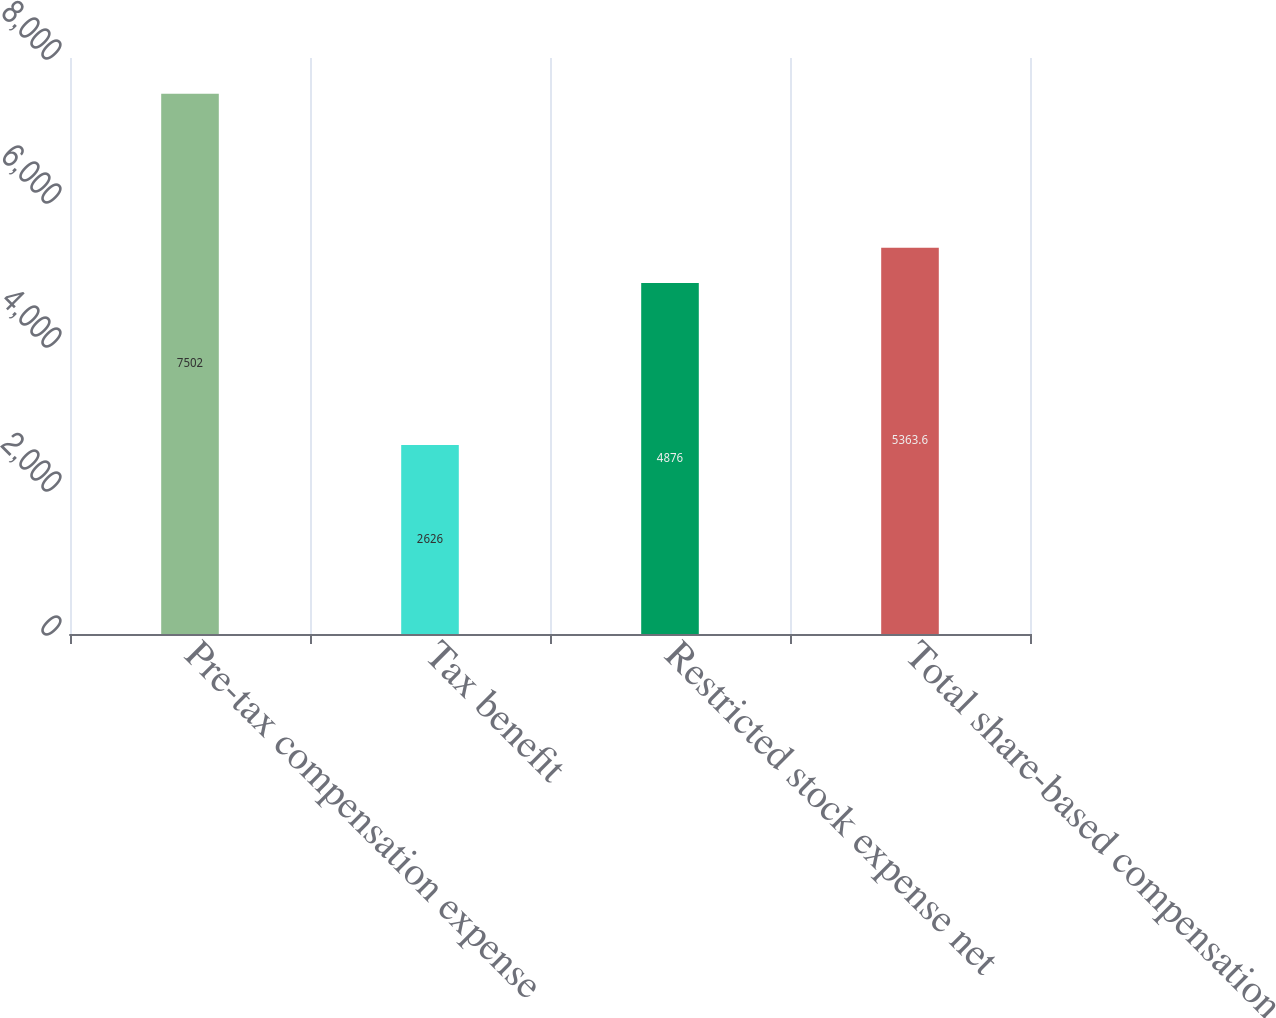<chart> <loc_0><loc_0><loc_500><loc_500><bar_chart><fcel>Pre-tax compensation expense<fcel>Tax benefit<fcel>Restricted stock expense net<fcel>Total share-based compensation<nl><fcel>7502<fcel>2626<fcel>4876<fcel>5363.6<nl></chart> 